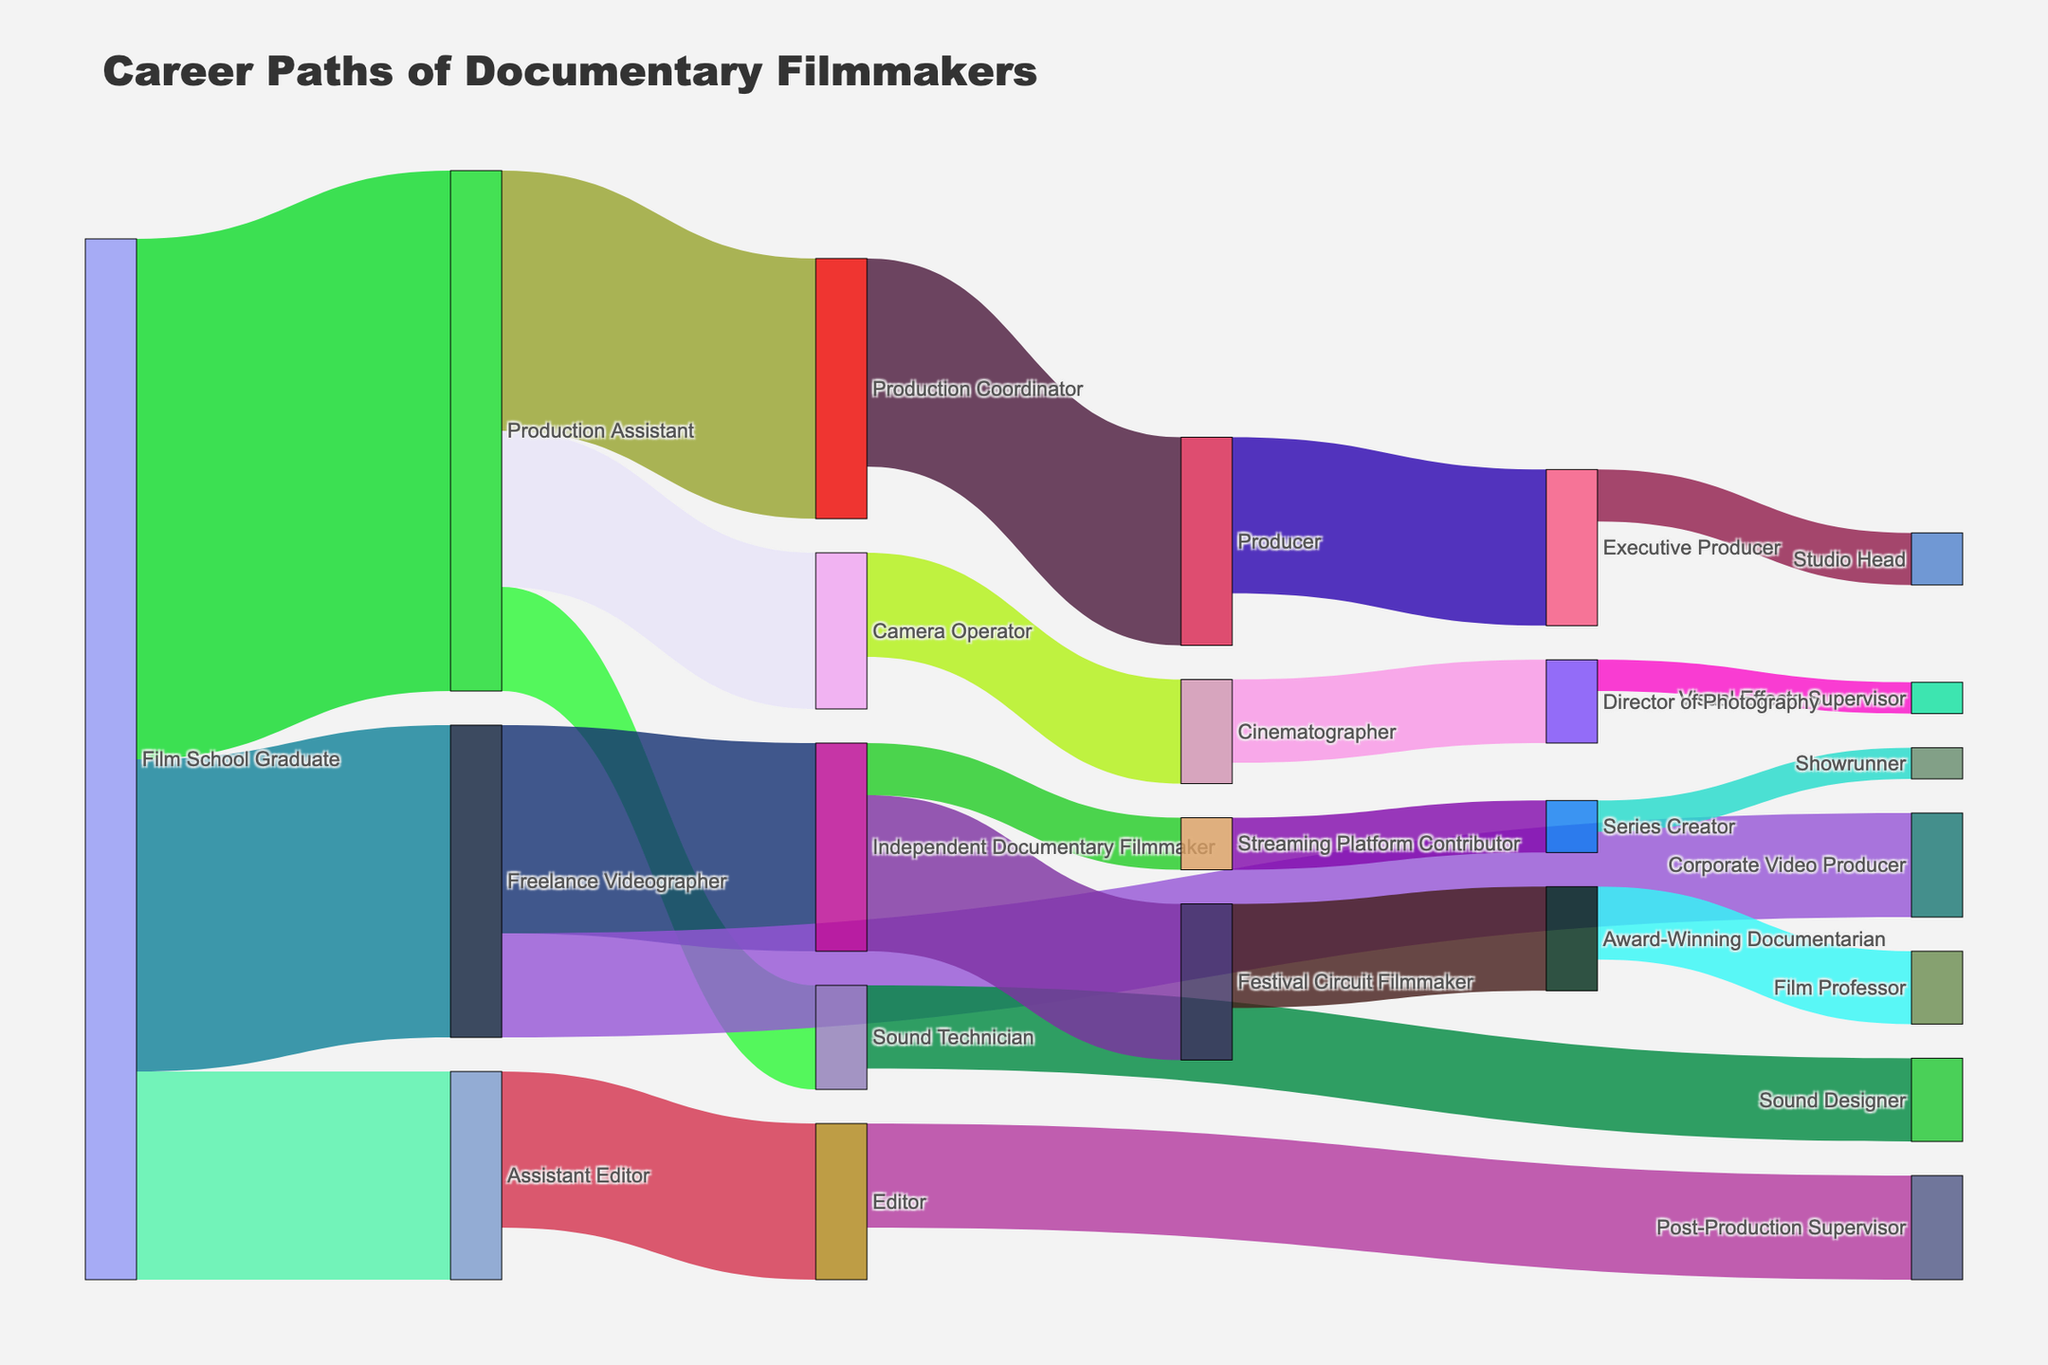Who predominantly transitions from being a Film School Graduate? By looking at the number of connections directed from the "Film School Graduate" node, it is clear that "Production Assistant" is the most frequent transition with a value of 50.
Answer: Production Assistant Which path has the highest individual value? By examining the values associated with each link, the highest single value is 50, which is the transition from "Film School Graduate" to "Production Assistant".
Answer: Film School Graduate to Production Assistant How many career transitions involve roles specifically categorized under 'production'? The roles under 'production' are Production Assistant, Production Coordinator, and Producer. The transitions related to these roles are:
1. Film School Graduate to Production Assistant (50)
2. Production Assistant to Production Coordinator (25)
3. Production Coordinator to Producer (20)
Therefore, there are three transitions involving 'production' roles.
Answer: 3 Which endpoint role has the fewest transition paths? By reviewing the final nodes (roles with no outgoing transitions), "Showrunner" has the fewest paths with only one transition from "Series Creator".
Answer: Showrunner What is the total number of people that transition from any role to becoming an "Executive Producer"? The only transition to "Executive Producer" is from "Producer", with a value of 15. Therefore, the total is 15.
Answer: 15 Are there more transitions to "Independent Documentary Filmmaker" or "Corporate Video Producer"? Comparing the values, "Freelance Videographer" transitions to "Independent Documentary Filmmaker" (20) and to "Corporate Video Producer" (10). 20 is greater than 10, hence there are more transitions to "Independent Documentary Filmmaker".
Answer: Independent Documentary Filmmaker Which role acts as a significant intermediary before transitioning to several other roles, and how many roles does it transition to? "Production Assistant" acts as a significant intermediary with transitions to four roles: Camera Operator (15), Sound Technician (10), Production Coordinator (25), and Sound Technician (10).
Answer: Production Assistant, 4 What is the second most common initial role for a "Producer"? The transitions to "Producer" are from "Production Coordinator" (20). Since this is the only role that transitions to "Producer," there is no second most common initial role.
Answer: None How many transitions involve the role of a "Cinematographer"? The role "Cinematographer" has one incoming (from "Camera Operator", value 10) and one outgoing transition (to "Director of Photography", value 8). Therefore, there are two transitions involving the role of "Cinematographer".
Answer: 2 Which role ultimately leads to becoming a "Studio Head"? The role "Executive Producer" transitions to "Studio Head" with a value of 5, indicating that "Executive Producer" can eventually lead to becoming a "Studio Head".
Answer: Executive Producer 